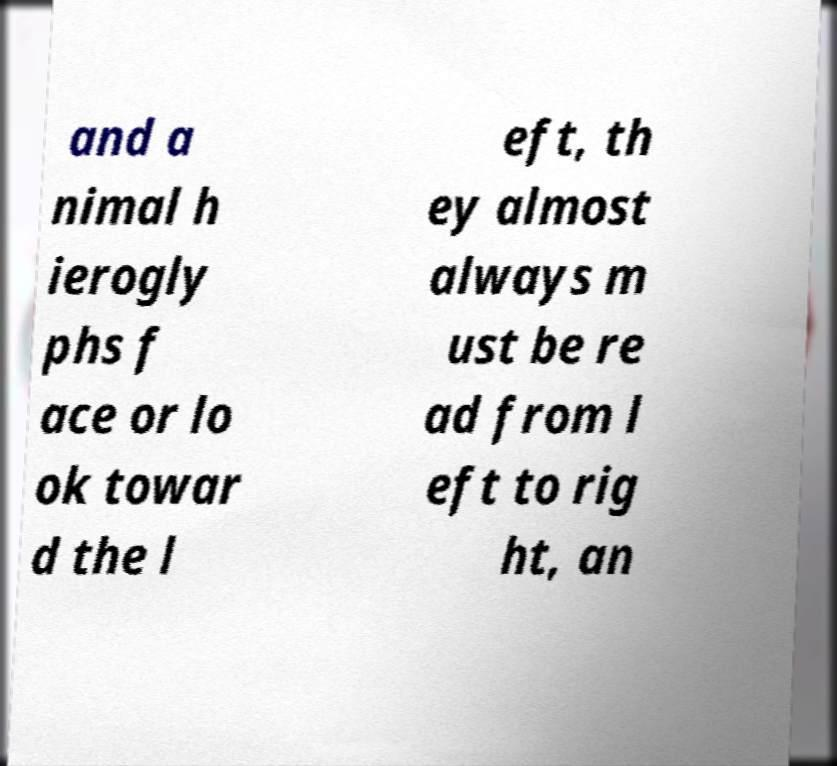Please identify and transcribe the text found in this image. and a nimal h ierogly phs f ace or lo ok towar d the l eft, th ey almost always m ust be re ad from l eft to rig ht, an 